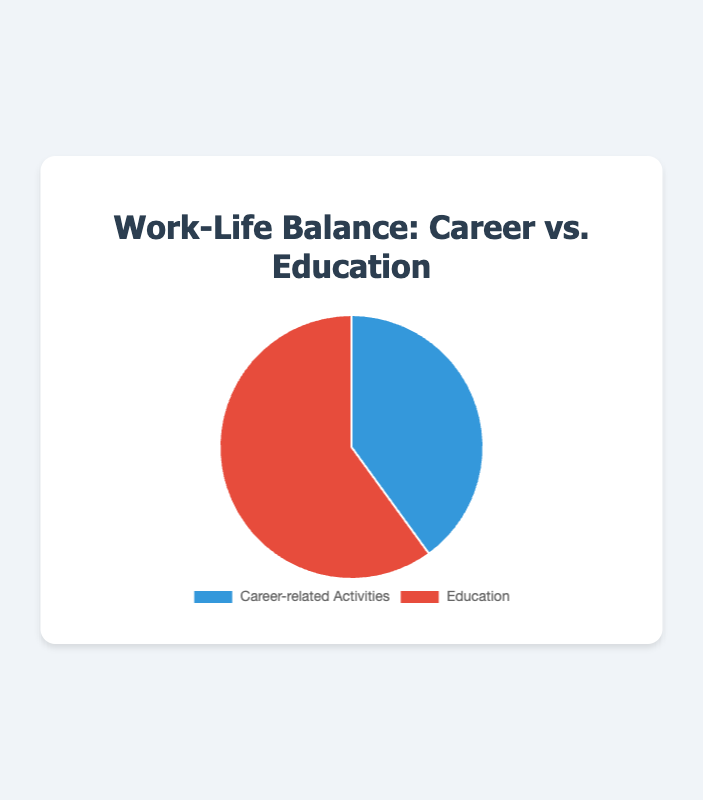What percentage of your week is spent on education compared to career-related activities? The total hours spent per week are 20 (career-related activities) + 30 (education) = 50 hours. The percentage of time spent on education is (30/50) * 100 = 60%.
Answer: 60% How many more hours per week do you spend on education than on career-related activities? You spend 30 hours on education and 20 hours on career-related activities. The difference is 30 - 20 = 10 hours.
Answer: 10 hours Which activity, career-related or education, takes up more of your time per week? Education takes up more time at 30 hours per week compared to career-related activities at 20 hours per week.
Answer: Education What fraction of your total weekly hours is dedicated to career-related activities? The total hours are 50. The fraction for career-related activities is 20/50, which simplifies to 2/5.
Answer: 2/5 What are the colors used to represent career-related activities and education in the pie chart? The pie chart uses blue for career-related activities and red for education.
Answer: blue (career-related activities), red (education) If you spent 5 more hours per week on career-related activities, what would the new percentage be for career-related activities? Initially, career-related activities are 20 hours and total hours are 50. With 5 more hours, career-related activities become 25 hours and total hours become 55. New percentage is (25/55) * 100 ≈ 45.45%.
Answer: approximately 45.45% If you were to equalize the hours spent on career-related activities and education, how much time would you allocate for each? The total number of hours (50) would be divided equally between the two activities, resulting in 25 hours for each.
Answer: 25 hours each What is the ratio of hours spent on education to hours spent on career-related activities? The ratio is 30 (education) to 20 (career-related activities), which simplifies to 3:2.
Answer: 3:2 